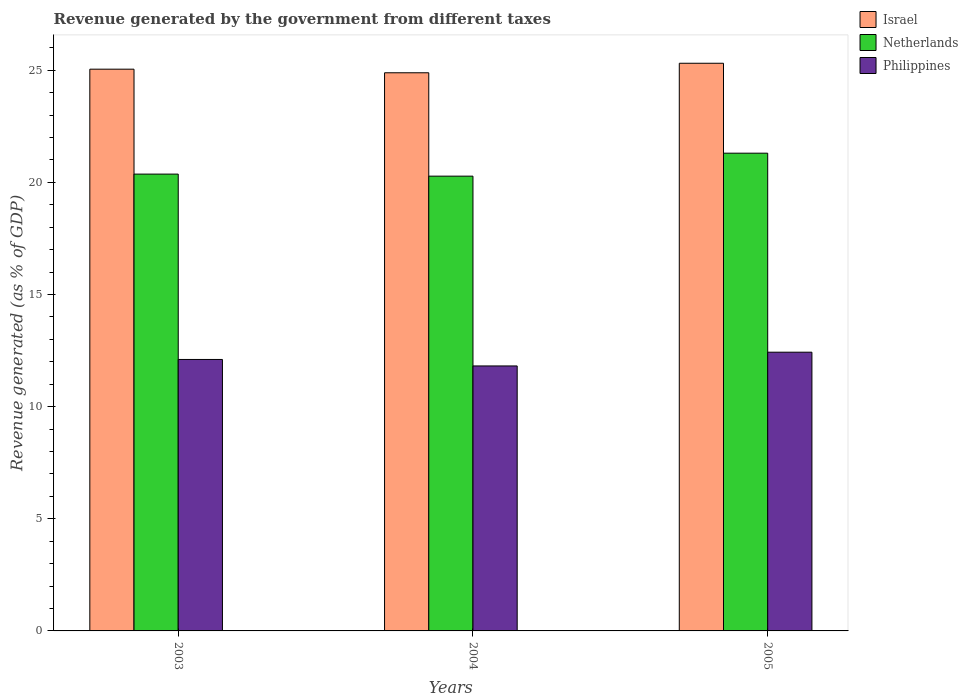How many groups of bars are there?
Your answer should be compact. 3. Are the number of bars per tick equal to the number of legend labels?
Ensure brevity in your answer.  Yes. How many bars are there on the 1st tick from the left?
Give a very brief answer. 3. How many bars are there on the 1st tick from the right?
Your answer should be very brief. 3. What is the revenue generated by the government in Philippines in 2005?
Offer a terse response. 12.43. Across all years, what is the maximum revenue generated by the government in Israel?
Offer a very short reply. 25.31. Across all years, what is the minimum revenue generated by the government in Israel?
Offer a terse response. 24.89. What is the total revenue generated by the government in Israel in the graph?
Keep it short and to the point. 75.24. What is the difference between the revenue generated by the government in Israel in 2003 and that in 2005?
Ensure brevity in your answer.  -0.26. What is the difference between the revenue generated by the government in Israel in 2005 and the revenue generated by the government in Netherlands in 2004?
Provide a short and direct response. 5.03. What is the average revenue generated by the government in Netherlands per year?
Give a very brief answer. 20.65. In the year 2003, what is the difference between the revenue generated by the government in Philippines and revenue generated by the government in Israel?
Your answer should be compact. -12.94. In how many years, is the revenue generated by the government in Philippines greater than 2 %?
Provide a succinct answer. 3. What is the ratio of the revenue generated by the government in Israel in 2003 to that in 2005?
Give a very brief answer. 0.99. Is the revenue generated by the government in Philippines in 2003 less than that in 2005?
Make the answer very short. Yes. Is the difference between the revenue generated by the government in Philippines in 2003 and 2005 greater than the difference between the revenue generated by the government in Israel in 2003 and 2005?
Offer a terse response. No. What is the difference between the highest and the second highest revenue generated by the government in Netherlands?
Offer a terse response. 0.93. What is the difference between the highest and the lowest revenue generated by the government in Netherlands?
Provide a succinct answer. 1.02. In how many years, is the revenue generated by the government in Israel greater than the average revenue generated by the government in Israel taken over all years?
Provide a succinct answer. 1. Is it the case that in every year, the sum of the revenue generated by the government in Netherlands and revenue generated by the government in Israel is greater than the revenue generated by the government in Philippines?
Your response must be concise. Yes. How many bars are there?
Your answer should be compact. 9. Where does the legend appear in the graph?
Offer a terse response. Top right. What is the title of the graph?
Your answer should be very brief. Revenue generated by the government from different taxes. Does "Antigua and Barbuda" appear as one of the legend labels in the graph?
Offer a terse response. No. What is the label or title of the X-axis?
Give a very brief answer. Years. What is the label or title of the Y-axis?
Offer a terse response. Revenue generated (as % of GDP). What is the Revenue generated (as % of GDP) in Israel in 2003?
Offer a terse response. 25.05. What is the Revenue generated (as % of GDP) in Netherlands in 2003?
Make the answer very short. 20.37. What is the Revenue generated (as % of GDP) in Philippines in 2003?
Make the answer very short. 12.1. What is the Revenue generated (as % of GDP) in Israel in 2004?
Provide a succinct answer. 24.89. What is the Revenue generated (as % of GDP) of Netherlands in 2004?
Offer a terse response. 20.28. What is the Revenue generated (as % of GDP) of Philippines in 2004?
Your answer should be compact. 11.81. What is the Revenue generated (as % of GDP) in Israel in 2005?
Offer a very short reply. 25.31. What is the Revenue generated (as % of GDP) of Netherlands in 2005?
Give a very brief answer. 21.3. What is the Revenue generated (as % of GDP) in Philippines in 2005?
Make the answer very short. 12.43. Across all years, what is the maximum Revenue generated (as % of GDP) of Israel?
Offer a very short reply. 25.31. Across all years, what is the maximum Revenue generated (as % of GDP) of Netherlands?
Ensure brevity in your answer.  21.3. Across all years, what is the maximum Revenue generated (as % of GDP) in Philippines?
Keep it short and to the point. 12.43. Across all years, what is the minimum Revenue generated (as % of GDP) of Israel?
Provide a short and direct response. 24.89. Across all years, what is the minimum Revenue generated (as % of GDP) in Netherlands?
Give a very brief answer. 20.28. Across all years, what is the minimum Revenue generated (as % of GDP) in Philippines?
Your answer should be very brief. 11.81. What is the total Revenue generated (as % of GDP) of Israel in the graph?
Make the answer very short. 75.24. What is the total Revenue generated (as % of GDP) in Netherlands in the graph?
Your answer should be very brief. 61.95. What is the total Revenue generated (as % of GDP) of Philippines in the graph?
Your answer should be compact. 36.35. What is the difference between the Revenue generated (as % of GDP) in Israel in 2003 and that in 2004?
Your answer should be compact. 0.16. What is the difference between the Revenue generated (as % of GDP) in Netherlands in 2003 and that in 2004?
Provide a short and direct response. 0.09. What is the difference between the Revenue generated (as % of GDP) in Philippines in 2003 and that in 2004?
Give a very brief answer. 0.29. What is the difference between the Revenue generated (as % of GDP) of Israel in 2003 and that in 2005?
Provide a short and direct response. -0.26. What is the difference between the Revenue generated (as % of GDP) in Netherlands in 2003 and that in 2005?
Make the answer very short. -0.93. What is the difference between the Revenue generated (as % of GDP) in Philippines in 2003 and that in 2005?
Your answer should be compact. -0.32. What is the difference between the Revenue generated (as % of GDP) in Israel in 2004 and that in 2005?
Keep it short and to the point. -0.42. What is the difference between the Revenue generated (as % of GDP) in Netherlands in 2004 and that in 2005?
Provide a succinct answer. -1.02. What is the difference between the Revenue generated (as % of GDP) in Philippines in 2004 and that in 2005?
Your answer should be compact. -0.61. What is the difference between the Revenue generated (as % of GDP) in Israel in 2003 and the Revenue generated (as % of GDP) in Netherlands in 2004?
Your response must be concise. 4.77. What is the difference between the Revenue generated (as % of GDP) of Israel in 2003 and the Revenue generated (as % of GDP) of Philippines in 2004?
Offer a very short reply. 13.23. What is the difference between the Revenue generated (as % of GDP) of Netherlands in 2003 and the Revenue generated (as % of GDP) of Philippines in 2004?
Provide a succinct answer. 8.55. What is the difference between the Revenue generated (as % of GDP) in Israel in 2003 and the Revenue generated (as % of GDP) in Netherlands in 2005?
Your answer should be very brief. 3.75. What is the difference between the Revenue generated (as % of GDP) in Israel in 2003 and the Revenue generated (as % of GDP) in Philippines in 2005?
Your answer should be very brief. 12.62. What is the difference between the Revenue generated (as % of GDP) of Netherlands in 2003 and the Revenue generated (as % of GDP) of Philippines in 2005?
Keep it short and to the point. 7.94. What is the difference between the Revenue generated (as % of GDP) in Israel in 2004 and the Revenue generated (as % of GDP) in Netherlands in 2005?
Your response must be concise. 3.58. What is the difference between the Revenue generated (as % of GDP) of Israel in 2004 and the Revenue generated (as % of GDP) of Philippines in 2005?
Keep it short and to the point. 12.46. What is the difference between the Revenue generated (as % of GDP) in Netherlands in 2004 and the Revenue generated (as % of GDP) in Philippines in 2005?
Your answer should be compact. 7.85. What is the average Revenue generated (as % of GDP) in Israel per year?
Provide a short and direct response. 25.08. What is the average Revenue generated (as % of GDP) of Netherlands per year?
Your response must be concise. 20.65. What is the average Revenue generated (as % of GDP) of Philippines per year?
Make the answer very short. 12.12. In the year 2003, what is the difference between the Revenue generated (as % of GDP) of Israel and Revenue generated (as % of GDP) of Netherlands?
Offer a terse response. 4.68. In the year 2003, what is the difference between the Revenue generated (as % of GDP) of Israel and Revenue generated (as % of GDP) of Philippines?
Provide a succinct answer. 12.94. In the year 2003, what is the difference between the Revenue generated (as % of GDP) of Netherlands and Revenue generated (as % of GDP) of Philippines?
Make the answer very short. 8.27. In the year 2004, what is the difference between the Revenue generated (as % of GDP) of Israel and Revenue generated (as % of GDP) of Netherlands?
Your answer should be compact. 4.61. In the year 2004, what is the difference between the Revenue generated (as % of GDP) in Israel and Revenue generated (as % of GDP) in Philippines?
Provide a short and direct response. 13.07. In the year 2004, what is the difference between the Revenue generated (as % of GDP) in Netherlands and Revenue generated (as % of GDP) in Philippines?
Keep it short and to the point. 8.46. In the year 2005, what is the difference between the Revenue generated (as % of GDP) of Israel and Revenue generated (as % of GDP) of Netherlands?
Your answer should be compact. 4.01. In the year 2005, what is the difference between the Revenue generated (as % of GDP) in Israel and Revenue generated (as % of GDP) in Philippines?
Offer a terse response. 12.88. In the year 2005, what is the difference between the Revenue generated (as % of GDP) of Netherlands and Revenue generated (as % of GDP) of Philippines?
Your response must be concise. 8.87. What is the ratio of the Revenue generated (as % of GDP) of Israel in 2003 to that in 2004?
Your answer should be compact. 1.01. What is the ratio of the Revenue generated (as % of GDP) in Philippines in 2003 to that in 2004?
Offer a terse response. 1.02. What is the ratio of the Revenue generated (as % of GDP) in Israel in 2003 to that in 2005?
Provide a succinct answer. 0.99. What is the ratio of the Revenue generated (as % of GDP) in Netherlands in 2003 to that in 2005?
Your answer should be compact. 0.96. What is the ratio of the Revenue generated (as % of GDP) of Philippines in 2003 to that in 2005?
Make the answer very short. 0.97. What is the ratio of the Revenue generated (as % of GDP) in Israel in 2004 to that in 2005?
Give a very brief answer. 0.98. What is the ratio of the Revenue generated (as % of GDP) of Netherlands in 2004 to that in 2005?
Make the answer very short. 0.95. What is the ratio of the Revenue generated (as % of GDP) in Philippines in 2004 to that in 2005?
Your answer should be compact. 0.95. What is the difference between the highest and the second highest Revenue generated (as % of GDP) of Israel?
Ensure brevity in your answer.  0.26. What is the difference between the highest and the second highest Revenue generated (as % of GDP) in Netherlands?
Make the answer very short. 0.93. What is the difference between the highest and the second highest Revenue generated (as % of GDP) in Philippines?
Offer a terse response. 0.32. What is the difference between the highest and the lowest Revenue generated (as % of GDP) of Israel?
Offer a terse response. 0.42. What is the difference between the highest and the lowest Revenue generated (as % of GDP) of Netherlands?
Give a very brief answer. 1.02. What is the difference between the highest and the lowest Revenue generated (as % of GDP) of Philippines?
Provide a short and direct response. 0.61. 